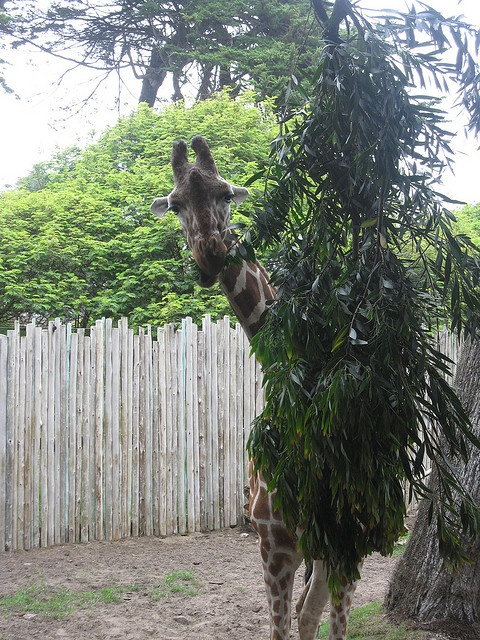Describe the objects in this image and their specific colors. I can see a giraffe in gray, black, darkgray, and darkgreen tones in this image. 